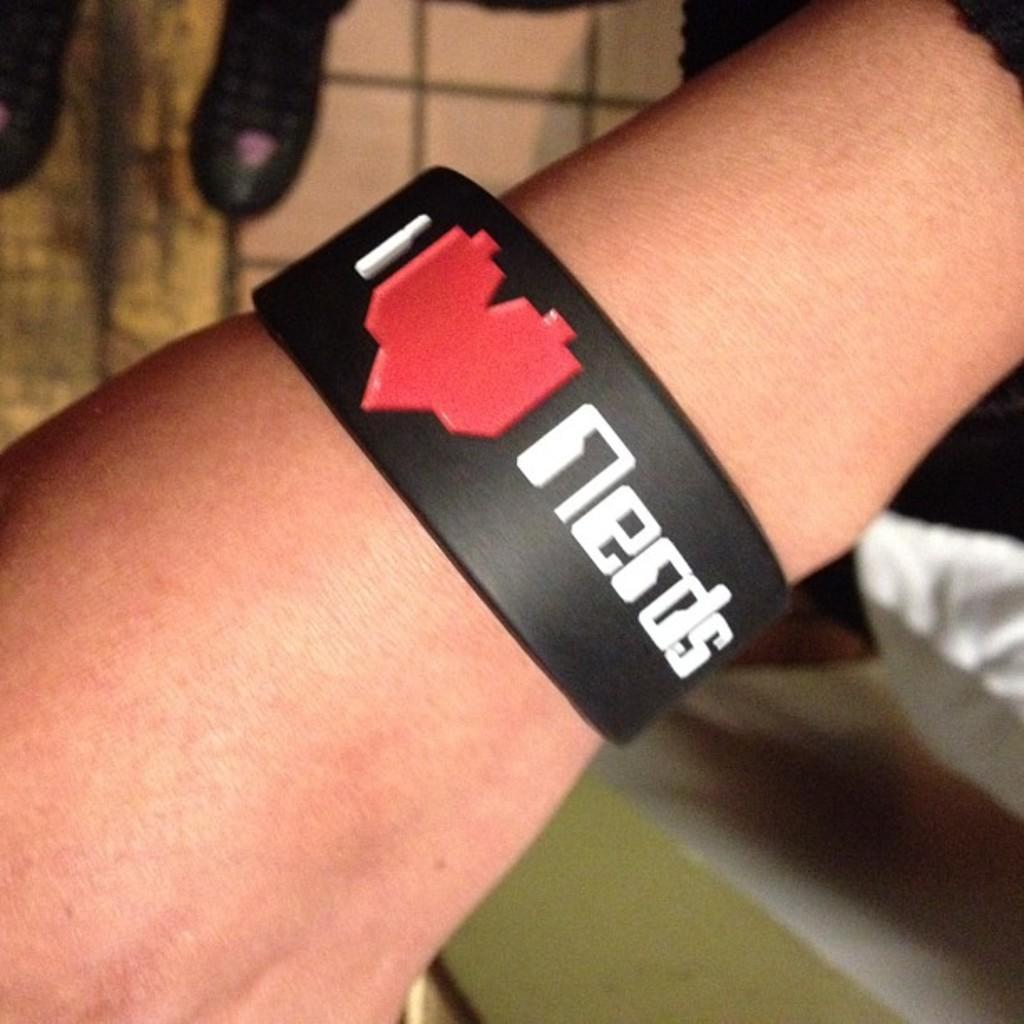What part of a person's body is visible in the foreground of the image? A person's hand is visible in the foreground of the image. What is on the person's hand? The person is wearing a band on their hand. What can be seen in the background of the image? There are objects and a wall in the background of the image. What page is the expert referencing in the image? There is no expert or page present in the image; it only shows a person's hand with a band on it and a background with objects and a wall. 